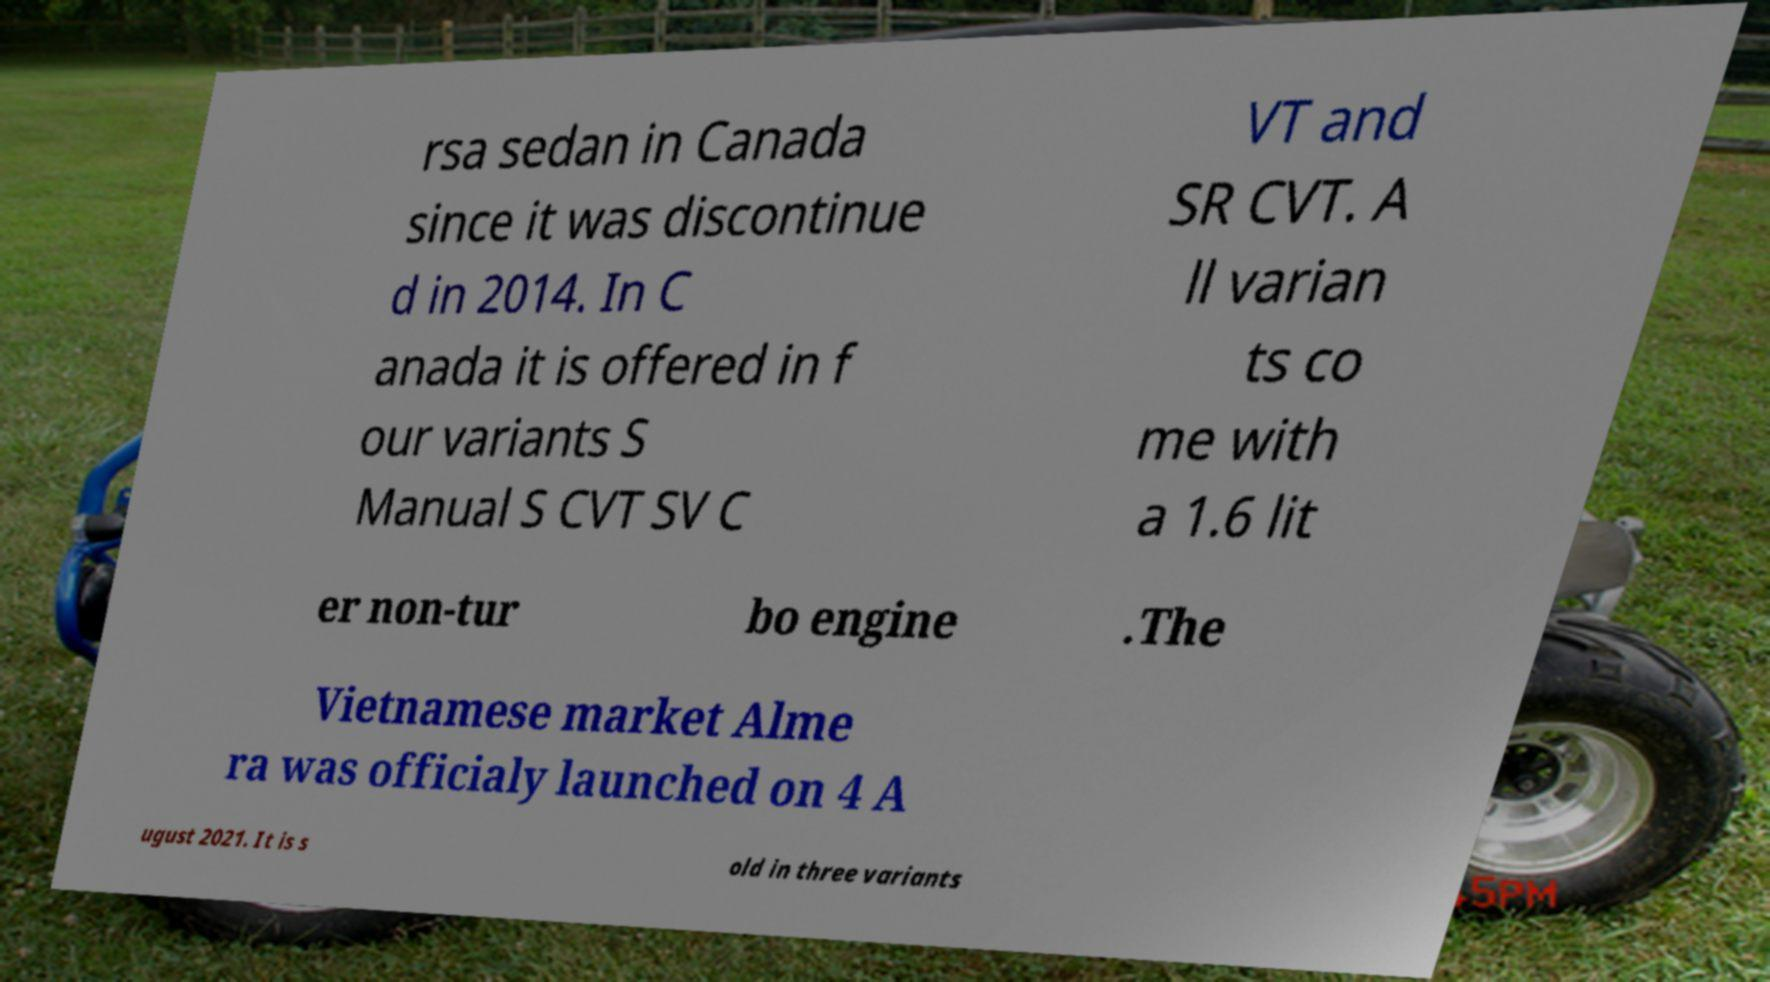Could you extract and type out the text from this image? rsa sedan in Canada since it was discontinue d in 2014. In C anada it is offered in f our variants S Manual S CVT SV C VT and SR CVT. A ll varian ts co me with a 1.6 lit er non-tur bo engine .The Vietnamese market Alme ra was officialy launched on 4 A ugust 2021. It is s old in three variants 